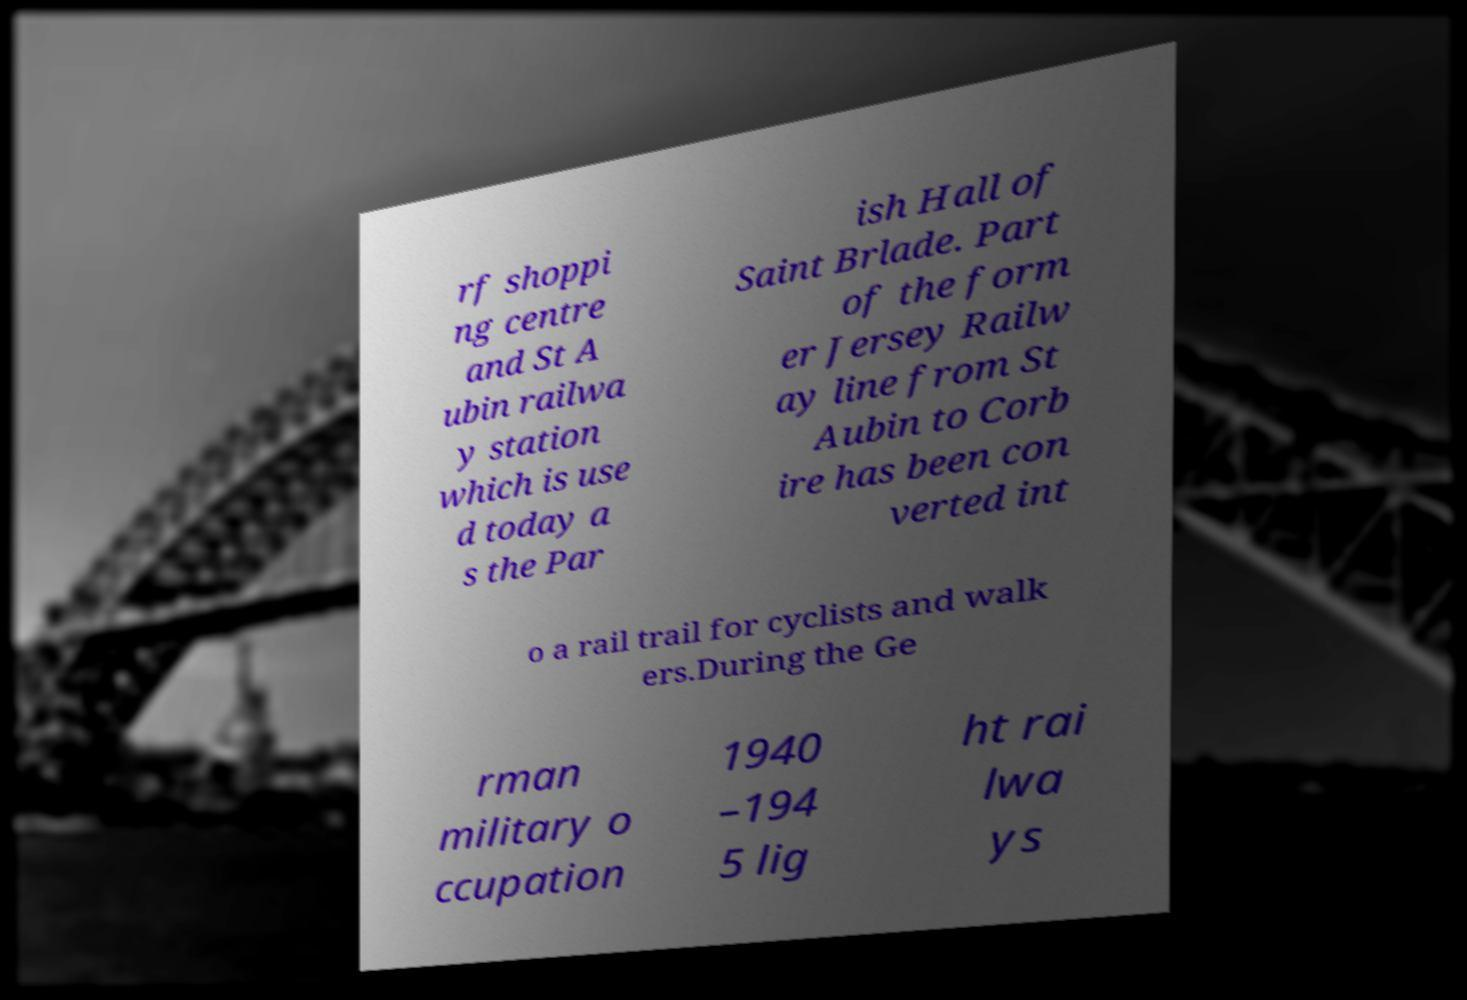Please identify and transcribe the text found in this image. rf shoppi ng centre and St A ubin railwa y station which is use d today a s the Par ish Hall of Saint Brlade. Part of the form er Jersey Railw ay line from St Aubin to Corb ire has been con verted int o a rail trail for cyclists and walk ers.During the Ge rman military o ccupation 1940 –194 5 lig ht rai lwa ys 